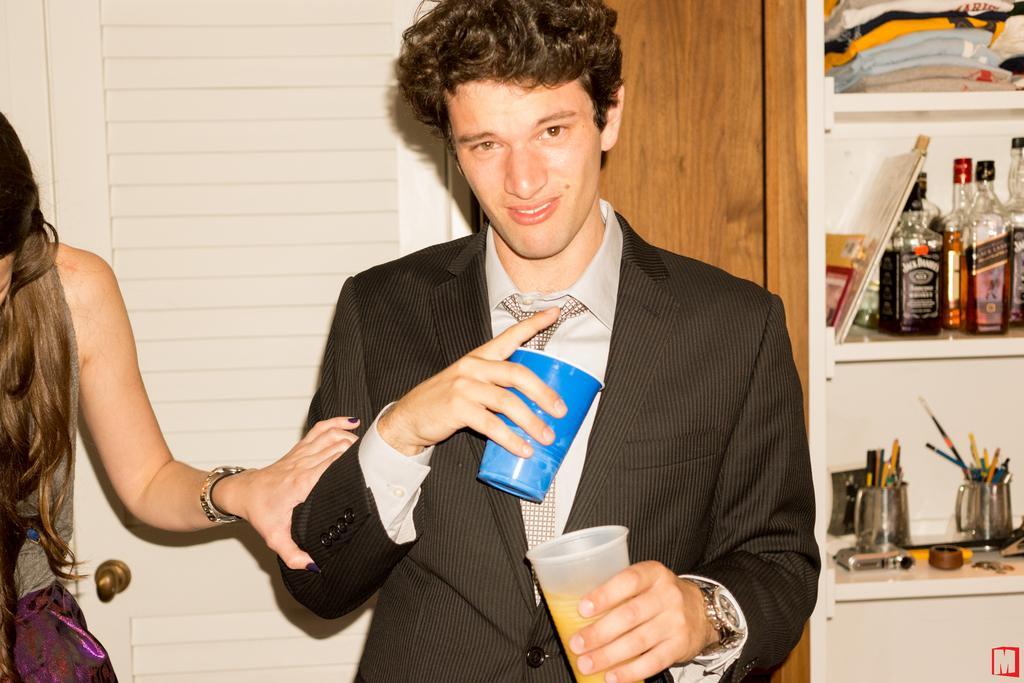In one or two sentences, can you explain what this image depicts? This is an inside view. Here I can see a man standing, holding two glasses in the hands, smiling and giving pose for the picture. O the left side there is a woman standing and holding this man's hand. On the right side there is a rack on which bottles, clothes, pens, bowls and some other objects are placed. At the back of these people there is a door. 